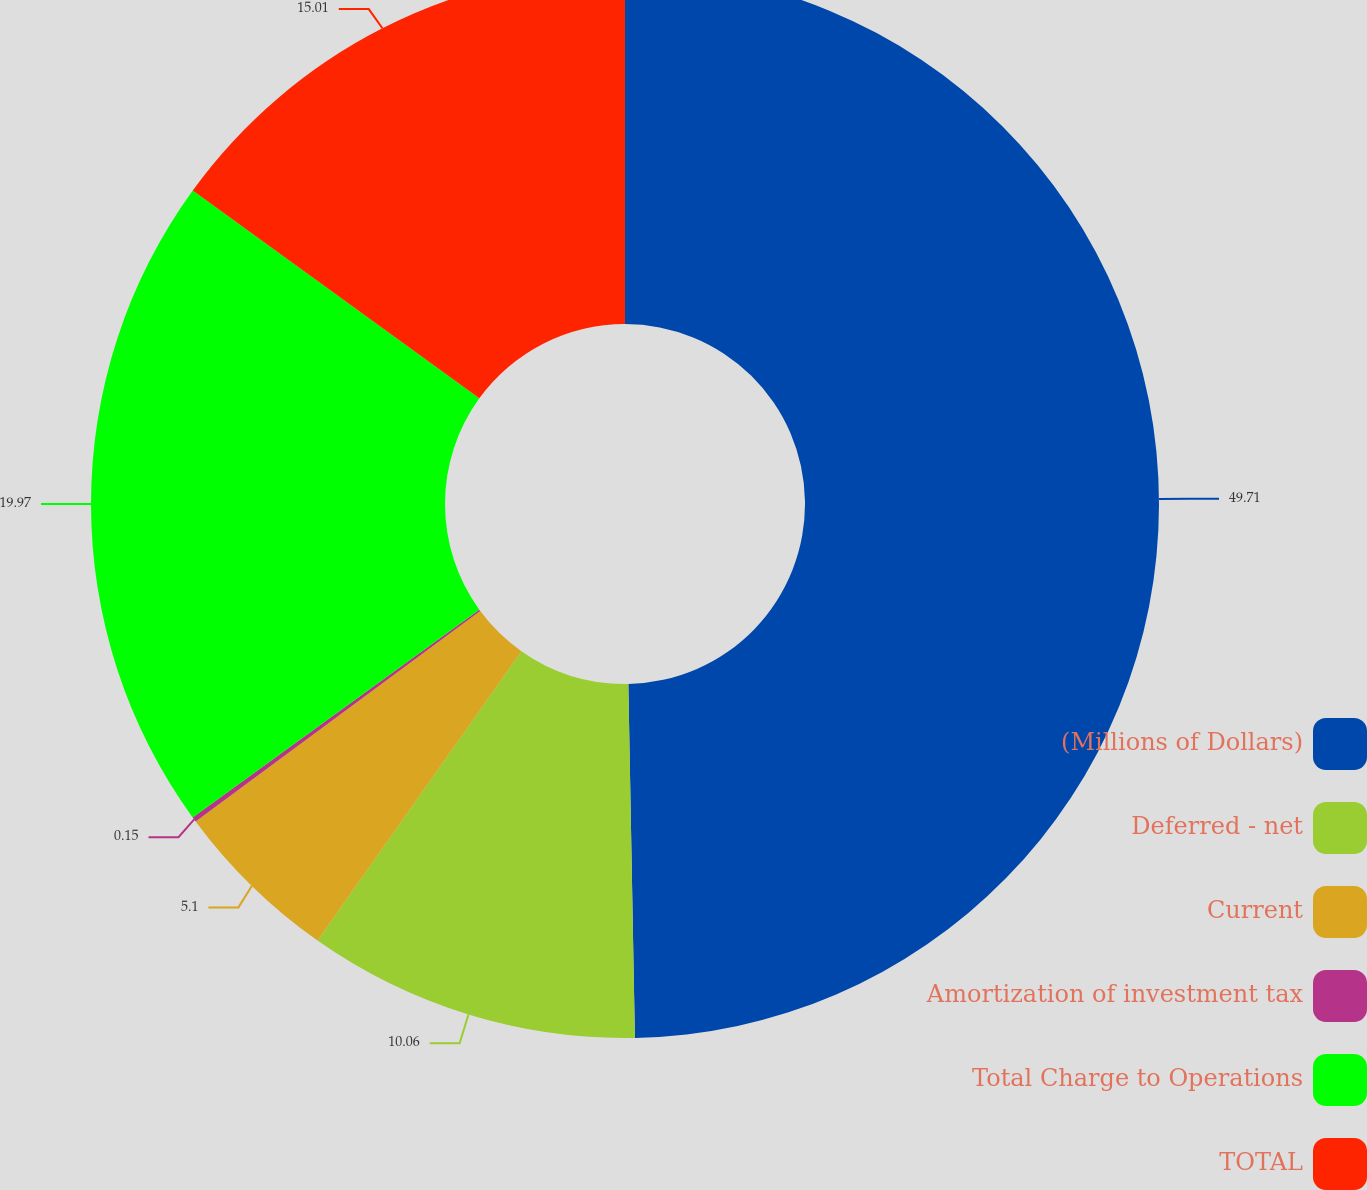Convert chart. <chart><loc_0><loc_0><loc_500><loc_500><pie_chart><fcel>(Millions of Dollars)<fcel>Deferred - net<fcel>Current<fcel>Amortization of investment tax<fcel>Total Charge to Operations<fcel>TOTAL<nl><fcel>49.7%<fcel>10.06%<fcel>5.1%<fcel>0.15%<fcel>19.97%<fcel>15.01%<nl></chart> 